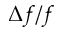Convert formula to latex. <formula><loc_0><loc_0><loc_500><loc_500>\Delta f / f</formula> 